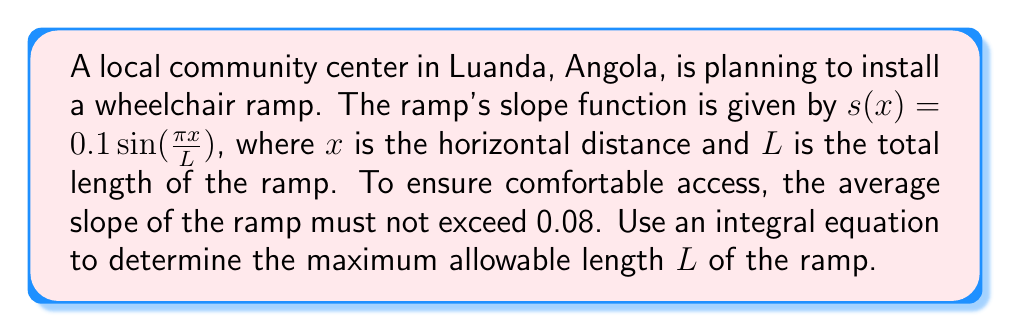What is the answer to this math problem? To solve this problem, we'll follow these steps:

1) The average slope of the ramp can be calculated using the integral:

   $$\text{Average Slope} = \frac{1}{L} \int_0^L s(x) dx$$

2) We need this average to be less than or equal to 0.08:

   $$\frac{1}{L} \int_0^L 0.1 \sin(\frac{\pi x}{L}) dx \leq 0.08$$

3) Let's solve the integral:

   $$\int_0^L 0.1 \sin(\frac{\pi x}{L}) dx = -\frac{0.1L}{\pi} \cos(\frac{\pi x}{L}) \bigg|_0^L$$
   
   $$= -\frac{0.1L}{\pi} [\cos(\pi) - \cos(0)] = -\frac{0.1L}{\pi} [-1 - 1] = \frac{0.2L}{\pi}$$

4) Substituting this back into our inequality:

   $$\frac{1}{L} \cdot \frac{0.2L}{\pi} \leq 0.08$$

5) Simplifying:

   $$\frac{0.2}{\pi} \leq 0.08$$

6) Solving for $L$:

   $$L \leq \frac{0.2}{0.08\pi} \approx 0.796$$

Therefore, the maximum allowable length of the ramp is approximately 0.796 meters or 79.6 cm.
Answer: $L \leq \frac{0.2}{0.08\pi} \approx 0.796$ meters 